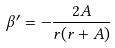Convert formula to latex. <formula><loc_0><loc_0><loc_500><loc_500>\beta ^ { \prime } = - \frac { 2 A } { r ( r + A ) }</formula> 